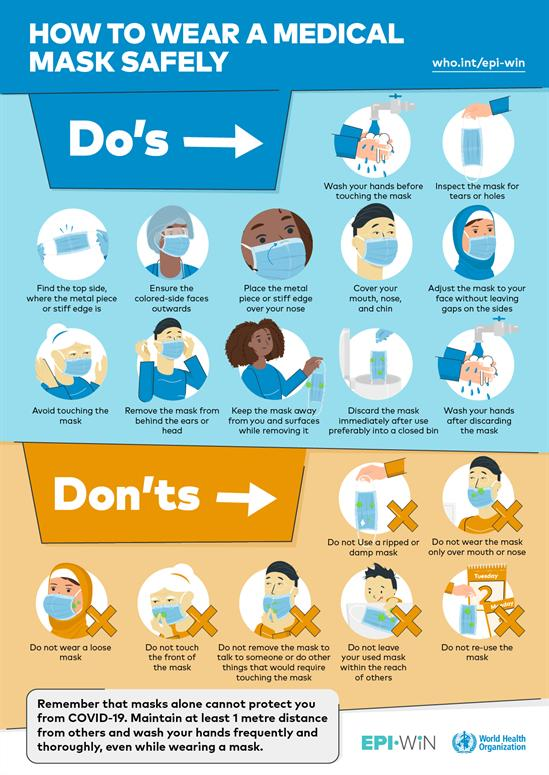Outline some significant characteristics in this image. There are 12 do's displayed in this infographic image. The infographic image demonstrates the presence of seven dos and don'ts. 